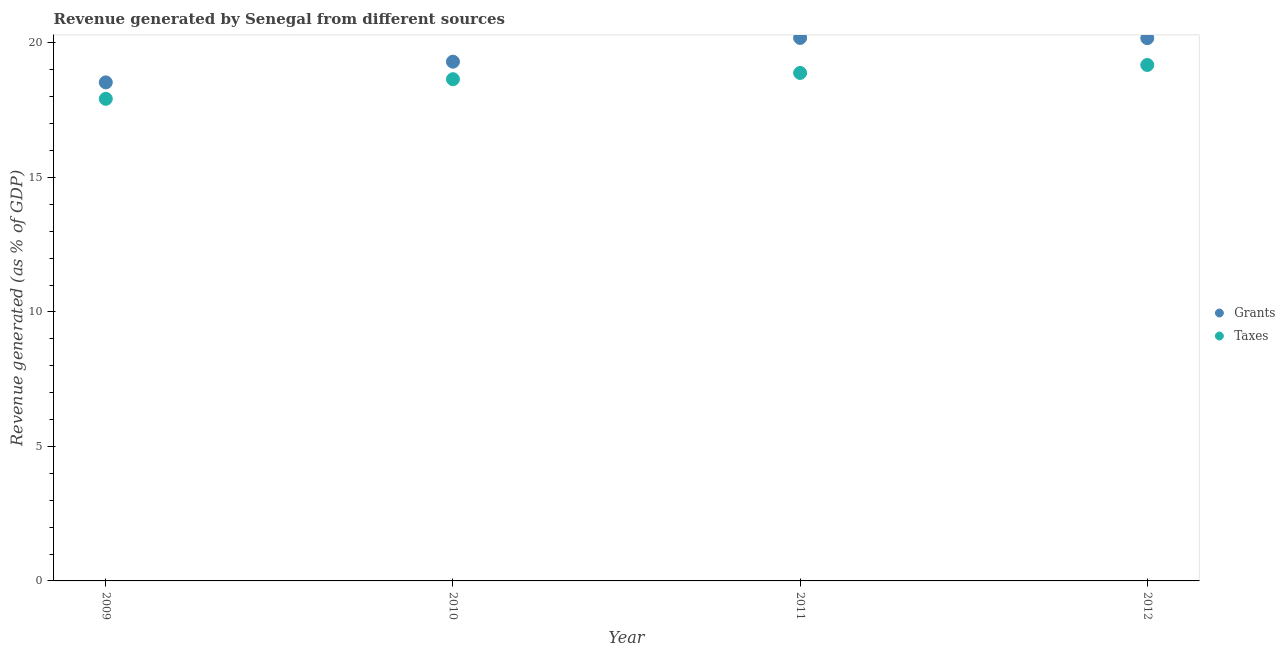Is the number of dotlines equal to the number of legend labels?
Keep it short and to the point. Yes. What is the revenue generated by taxes in 2009?
Offer a very short reply. 17.92. Across all years, what is the maximum revenue generated by taxes?
Offer a terse response. 19.18. Across all years, what is the minimum revenue generated by grants?
Make the answer very short. 18.54. In which year was the revenue generated by taxes maximum?
Your response must be concise. 2012. In which year was the revenue generated by grants minimum?
Your answer should be compact. 2009. What is the total revenue generated by taxes in the graph?
Keep it short and to the point. 74.64. What is the difference between the revenue generated by grants in 2011 and that in 2012?
Keep it short and to the point. 0.01. What is the difference between the revenue generated by grants in 2012 and the revenue generated by taxes in 2009?
Your response must be concise. 2.26. What is the average revenue generated by taxes per year?
Offer a terse response. 18.66. In the year 2009, what is the difference between the revenue generated by taxes and revenue generated by grants?
Give a very brief answer. -0.61. In how many years, is the revenue generated by grants greater than 3 %?
Make the answer very short. 4. What is the ratio of the revenue generated by grants in 2009 to that in 2011?
Provide a succinct answer. 0.92. What is the difference between the highest and the second highest revenue generated by grants?
Provide a short and direct response. 0.01. What is the difference between the highest and the lowest revenue generated by grants?
Offer a terse response. 1.65. Does the revenue generated by grants monotonically increase over the years?
Give a very brief answer. No. Is the revenue generated by taxes strictly greater than the revenue generated by grants over the years?
Your answer should be very brief. No. Is the revenue generated by grants strictly less than the revenue generated by taxes over the years?
Your answer should be very brief. No. How many dotlines are there?
Keep it short and to the point. 2. What is the difference between two consecutive major ticks on the Y-axis?
Your answer should be compact. 5. Does the graph contain any zero values?
Offer a terse response. No. Does the graph contain grids?
Provide a succinct answer. No. How many legend labels are there?
Your answer should be very brief. 2. How are the legend labels stacked?
Your answer should be very brief. Vertical. What is the title of the graph?
Offer a terse response. Revenue generated by Senegal from different sources. Does "Services" appear as one of the legend labels in the graph?
Keep it short and to the point. No. What is the label or title of the Y-axis?
Give a very brief answer. Revenue generated (as % of GDP). What is the Revenue generated (as % of GDP) of Grants in 2009?
Give a very brief answer. 18.54. What is the Revenue generated (as % of GDP) of Taxes in 2009?
Provide a short and direct response. 17.92. What is the Revenue generated (as % of GDP) in Grants in 2010?
Your response must be concise. 19.3. What is the Revenue generated (as % of GDP) in Taxes in 2010?
Offer a terse response. 18.65. What is the Revenue generated (as % of GDP) of Grants in 2011?
Offer a very short reply. 20.19. What is the Revenue generated (as % of GDP) of Taxes in 2011?
Provide a succinct answer. 18.89. What is the Revenue generated (as % of GDP) of Grants in 2012?
Keep it short and to the point. 20.18. What is the Revenue generated (as % of GDP) in Taxes in 2012?
Offer a terse response. 19.18. Across all years, what is the maximum Revenue generated (as % of GDP) of Grants?
Keep it short and to the point. 20.19. Across all years, what is the maximum Revenue generated (as % of GDP) of Taxes?
Your answer should be compact. 19.18. Across all years, what is the minimum Revenue generated (as % of GDP) of Grants?
Offer a very short reply. 18.54. Across all years, what is the minimum Revenue generated (as % of GDP) of Taxes?
Provide a short and direct response. 17.92. What is the total Revenue generated (as % of GDP) in Grants in the graph?
Offer a terse response. 78.21. What is the total Revenue generated (as % of GDP) in Taxes in the graph?
Your answer should be very brief. 74.64. What is the difference between the Revenue generated (as % of GDP) in Grants in 2009 and that in 2010?
Ensure brevity in your answer.  -0.77. What is the difference between the Revenue generated (as % of GDP) of Taxes in 2009 and that in 2010?
Your answer should be very brief. -0.73. What is the difference between the Revenue generated (as % of GDP) of Grants in 2009 and that in 2011?
Provide a succinct answer. -1.65. What is the difference between the Revenue generated (as % of GDP) of Taxes in 2009 and that in 2011?
Offer a terse response. -0.96. What is the difference between the Revenue generated (as % of GDP) in Grants in 2009 and that in 2012?
Ensure brevity in your answer.  -1.64. What is the difference between the Revenue generated (as % of GDP) of Taxes in 2009 and that in 2012?
Provide a short and direct response. -1.26. What is the difference between the Revenue generated (as % of GDP) of Grants in 2010 and that in 2011?
Offer a terse response. -0.88. What is the difference between the Revenue generated (as % of GDP) of Taxes in 2010 and that in 2011?
Make the answer very short. -0.23. What is the difference between the Revenue generated (as % of GDP) of Grants in 2010 and that in 2012?
Ensure brevity in your answer.  -0.87. What is the difference between the Revenue generated (as % of GDP) in Taxes in 2010 and that in 2012?
Provide a succinct answer. -0.53. What is the difference between the Revenue generated (as % of GDP) in Grants in 2011 and that in 2012?
Offer a very short reply. 0.01. What is the difference between the Revenue generated (as % of GDP) in Taxes in 2011 and that in 2012?
Offer a terse response. -0.3. What is the difference between the Revenue generated (as % of GDP) in Grants in 2009 and the Revenue generated (as % of GDP) in Taxes in 2010?
Keep it short and to the point. -0.12. What is the difference between the Revenue generated (as % of GDP) of Grants in 2009 and the Revenue generated (as % of GDP) of Taxes in 2011?
Offer a terse response. -0.35. What is the difference between the Revenue generated (as % of GDP) in Grants in 2009 and the Revenue generated (as % of GDP) in Taxes in 2012?
Your answer should be compact. -0.65. What is the difference between the Revenue generated (as % of GDP) in Grants in 2010 and the Revenue generated (as % of GDP) in Taxes in 2011?
Make the answer very short. 0.42. What is the difference between the Revenue generated (as % of GDP) in Grants in 2010 and the Revenue generated (as % of GDP) in Taxes in 2012?
Keep it short and to the point. 0.12. What is the difference between the Revenue generated (as % of GDP) in Grants in 2011 and the Revenue generated (as % of GDP) in Taxes in 2012?
Ensure brevity in your answer.  1.01. What is the average Revenue generated (as % of GDP) in Grants per year?
Your response must be concise. 19.55. What is the average Revenue generated (as % of GDP) in Taxes per year?
Your answer should be very brief. 18.66. In the year 2009, what is the difference between the Revenue generated (as % of GDP) in Grants and Revenue generated (as % of GDP) in Taxes?
Your answer should be very brief. 0.61. In the year 2010, what is the difference between the Revenue generated (as % of GDP) in Grants and Revenue generated (as % of GDP) in Taxes?
Ensure brevity in your answer.  0.65. In the year 2011, what is the difference between the Revenue generated (as % of GDP) of Grants and Revenue generated (as % of GDP) of Taxes?
Your response must be concise. 1.3. What is the ratio of the Revenue generated (as % of GDP) of Grants in 2009 to that in 2010?
Offer a very short reply. 0.96. What is the ratio of the Revenue generated (as % of GDP) of Taxes in 2009 to that in 2010?
Your answer should be very brief. 0.96. What is the ratio of the Revenue generated (as % of GDP) of Grants in 2009 to that in 2011?
Provide a short and direct response. 0.92. What is the ratio of the Revenue generated (as % of GDP) of Taxes in 2009 to that in 2011?
Ensure brevity in your answer.  0.95. What is the ratio of the Revenue generated (as % of GDP) of Grants in 2009 to that in 2012?
Make the answer very short. 0.92. What is the ratio of the Revenue generated (as % of GDP) of Taxes in 2009 to that in 2012?
Provide a succinct answer. 0.93. What is the ratio of the Revenue generated (as % of GDP) of Grants in 2010 to that in 2011?
Ensure brevity in your answer.  0.96. What is the ratio of the Revenue generated (as % of GDP) of Taxes in 2010 to that in 2011?
Make the answer very short. 0.99. What is the ratio of the Revenue generated (as % of GDP) in Grants in 2010 to that in 2012?
Your answer should be compact. 0.96. What is the ratio of the Revenue generated (as % of GDP) in Taxes in 2010 to that in 2012?
Your answer should be very brief. 0.97. What is the ratio of the Revenue generated (as % of GDP) in Grants in 2011 to that in 2012?
Offer a terse response. 1. What is the ratio of the Revenue generated (as % of GDP) of Taxes in 2011 to that in 2012?
Your answer should be compact. 0.98. What is the difference between the highest and the second highest Revenue generated (as % of GDP) of Grants?
Offer a terse response. 0.01. What is the difference between the highest and the second highest Revenue generated (as % of GDP) of Taxes?
Keep it short and to the point. 0.3. What is the difference between the highest and the lowest Revenue generated (as % of GDP) in Grants?
Provide a short and direct response. 1.65. What is the difference between the highest and the lowest Revenue generated (as % of GDP) of Taxes?
Ensure brevity in your answer.  1.26. 